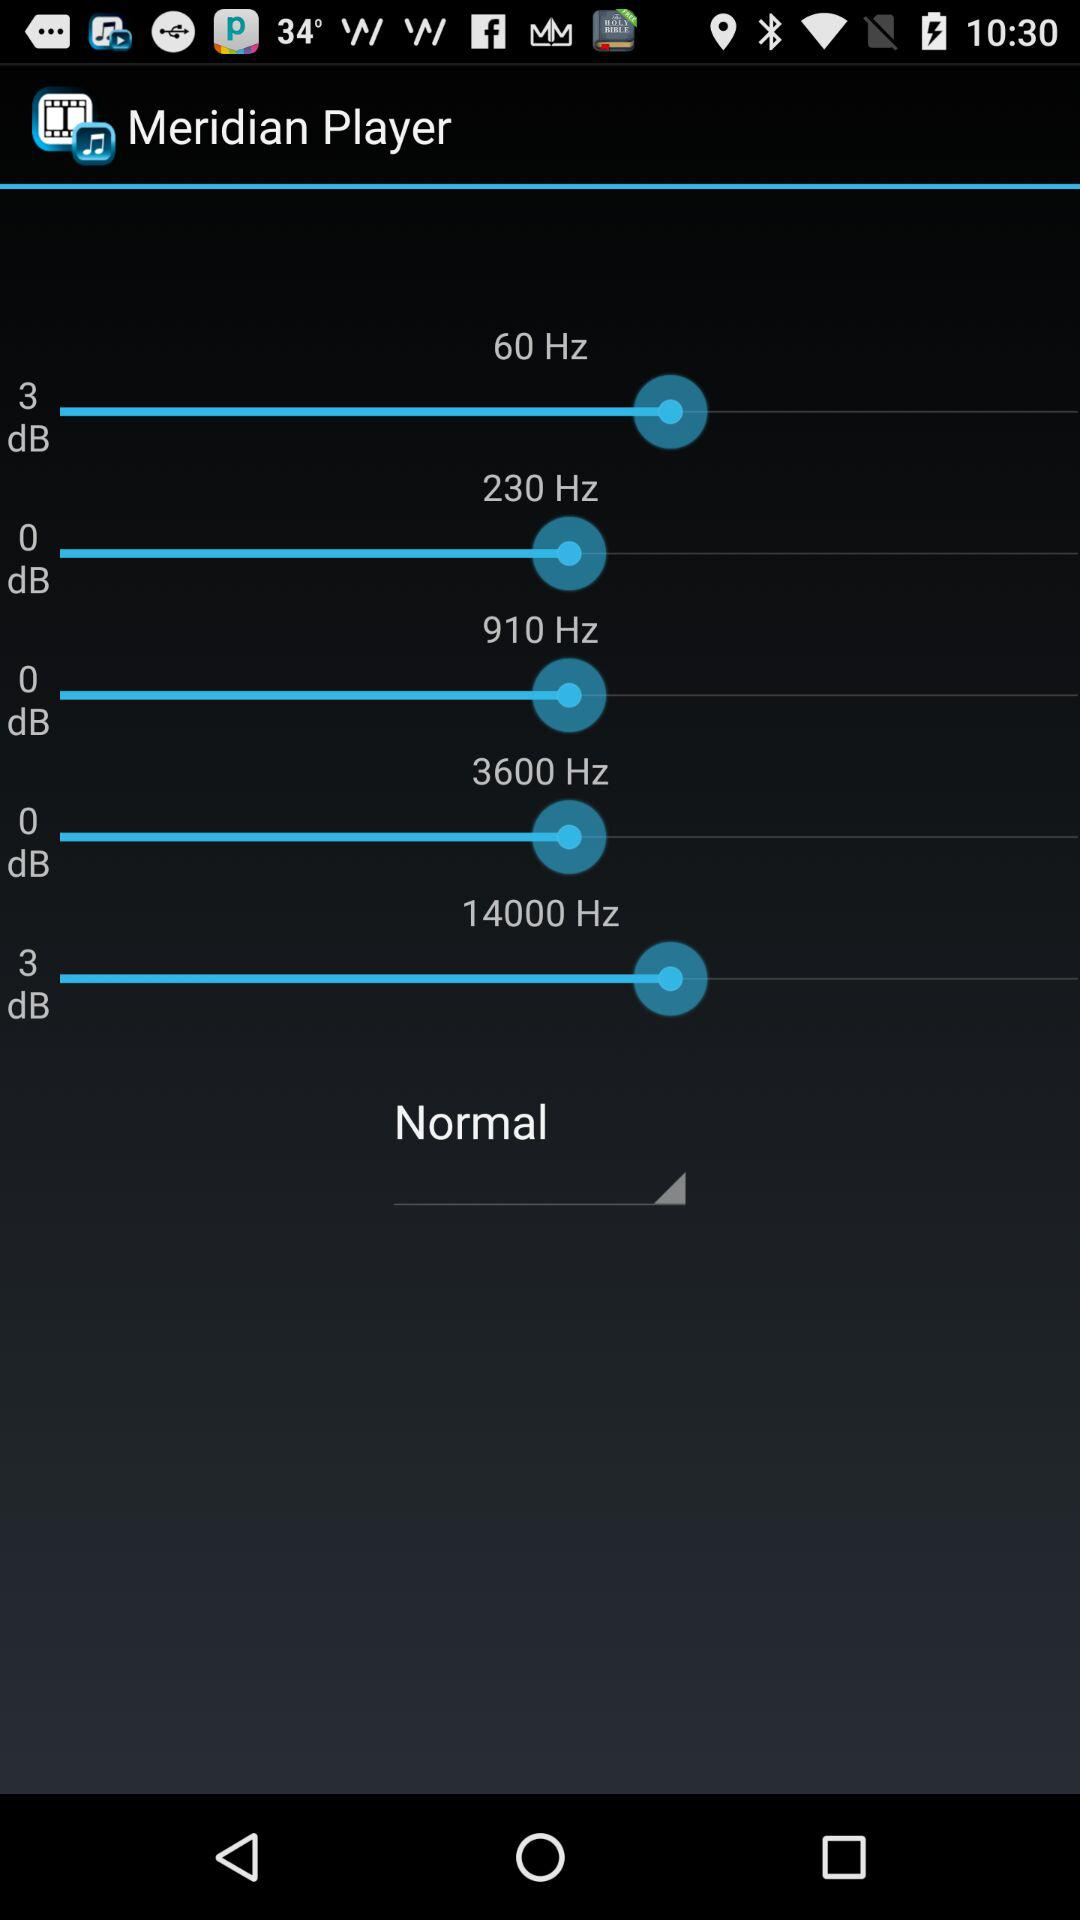How many frequencies are there with a volume of 0dB?
Answer the question using a single word or phrase. 3 